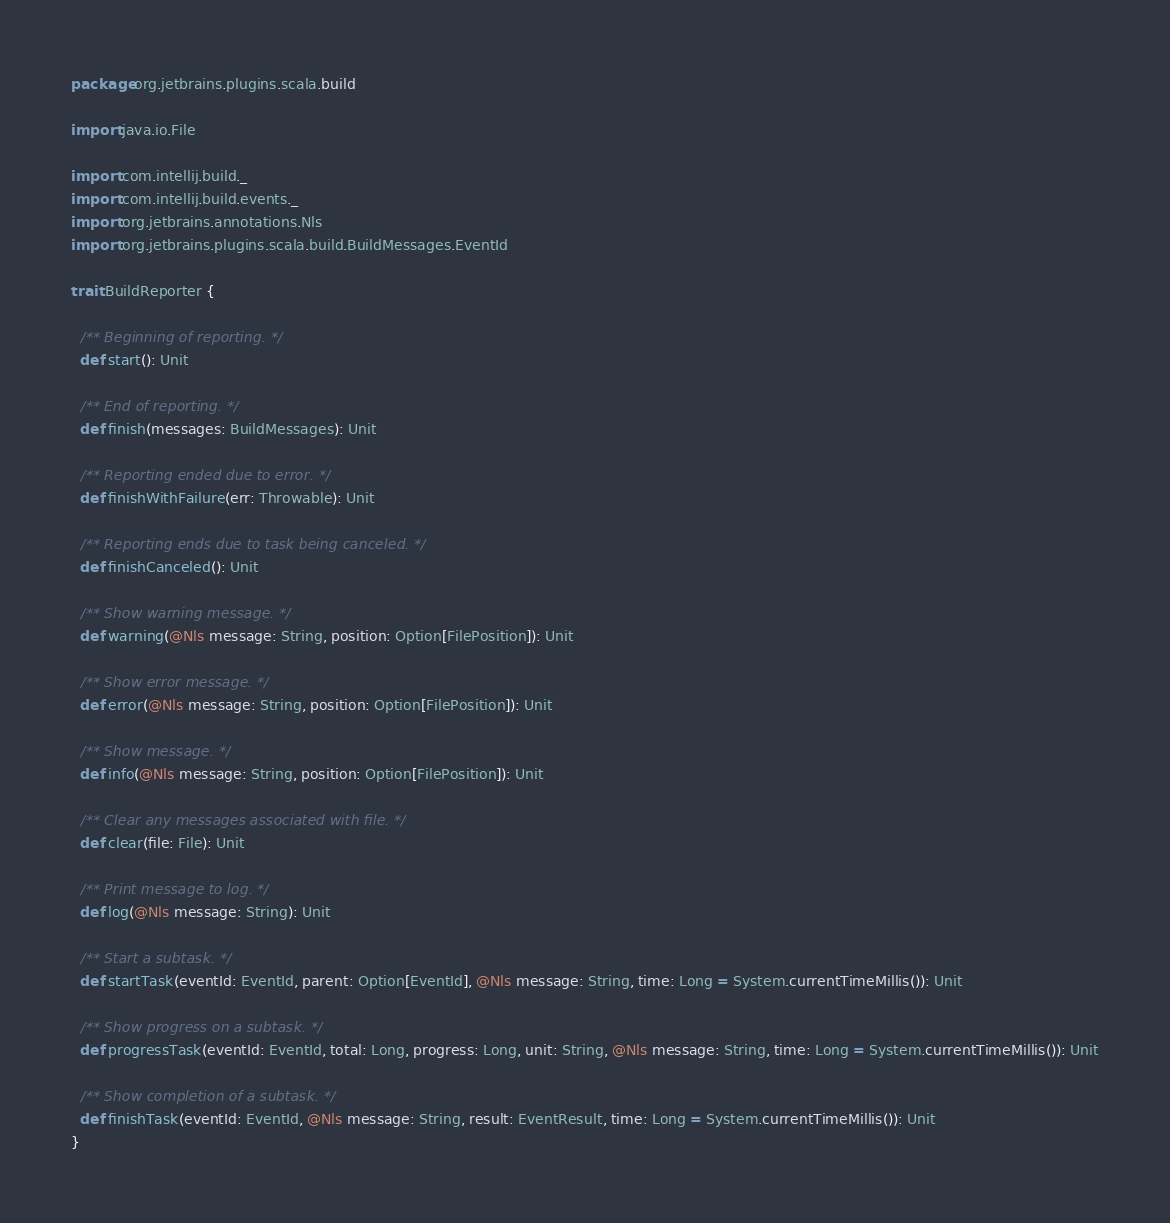<code> <loc_0><loc_0><loc_500><loc_500><_Scala_>package org.jetbrains.plugins.scala.build

import java.io.File

import com.intellij.build._
import com.intellij.build.events._
import org.jetbrains.annotations.Nls
import org.jetbrains.plugins.scala.build.BuildMessages.EventId

trait BuildReporter {

  /** Beginning of reporting. */
  def start(): Unit

  /** End of reporting. */
  def finish(messages: BuildMessages): Unit

  /** Reporting ended due to error. */
  def finishWithFailure(err: Throwable): Unit

  /** Reporting ends due to task being canceled. */
  def finishCanceled(): Unit

  /** Show warning message. */
  def warning(@Nls message: String, position: Option[FilePosition]): Unit

  /** Show error message. */
  def error(@Nls message: String, position: Option[FilePosition]): Unit

  /** Show message. */
  def info(@Nls message: String, position: Option[FilePosition]): Unit

  /** Clear any messages associated with file. */
  def clear(file: File): Unit

  /** Print message to log. */
  def log(@Nls message: String): Unit

  /** Start a subtask. */
  def startTask(eventId: EventId, parent: Option[EventId], @Nls message: String, time: Long = System.currentTimeMillis()): Unit

  /** Show progress on a subtask. */
  def progressTask(eventId: EventId, total: Long, progress: Long, unit: String, @Nls message: String, time: Long = System.currentTimeMillis()): Unit

  /** Show completion of a subtask. */
  def finishTask(eventId: EventId, @Nls message: String, result: EventResult, time: Long = System.currentTimeMillis()): Unit
}

</code> 